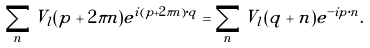<formula> <loc_0><loc_0><loc_500><loc_500>\sum _ { n } V _ { l } ( { p } + 2 \pi { n } ) e ^ { i ( { p } + 2 \pi { n } ) \cdot { q } } = \sum _ { n } \tilde { V } _ { l } ( { q } + { n } ) e ^ { - i { p } \cdot { n } } .</formula> 